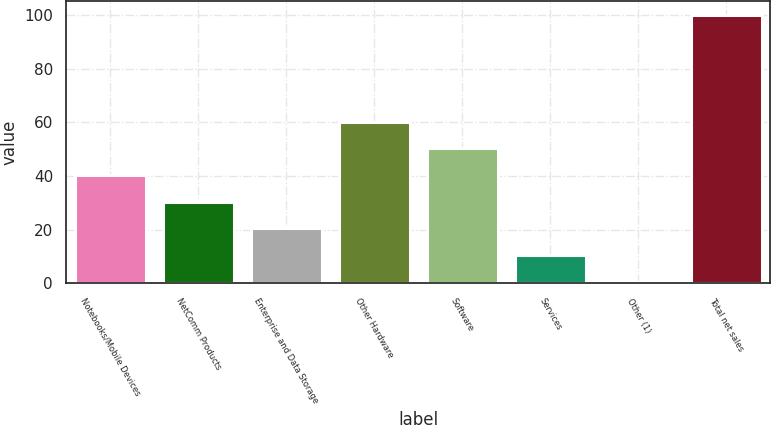Convert chart. <chart><loc_0><loc_0><loc_500><loc_500><bar_chart><fcel>Notebooks/Mobile Devices<fcel>NetComm Products<fcel>Enterprise and Data Storage<fcel>Other Hardware<fcel>Software<fcel>Services<fcel>Other (1)<fcel>Total net sales<nl><fcel>40.42<fcel>30.49<fcel>20.56<fcel>60.28<fcel>50.35<fcel>10.63<fcel>0.7<fcel>100<nl></chart> 